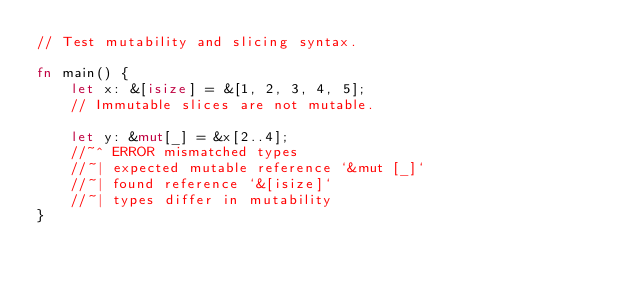Convert code to text. <code><loc_0><loc_0><loc_500><loc_500><_Rust_>// Test mutability and slicing syntax.

fn main() {
    let x: &[isize] = &[1, 2, 3, 4, 5];
    // Immutable slices are not mutable.

    let y: &mut[_] = &x[2..4];
    //~^ ERROR mismatched types
    //~| expected mutable reference `&mut [_]`
    //~| found reference `&[isize]`
    //~| types differ in mutability
}
</code> 